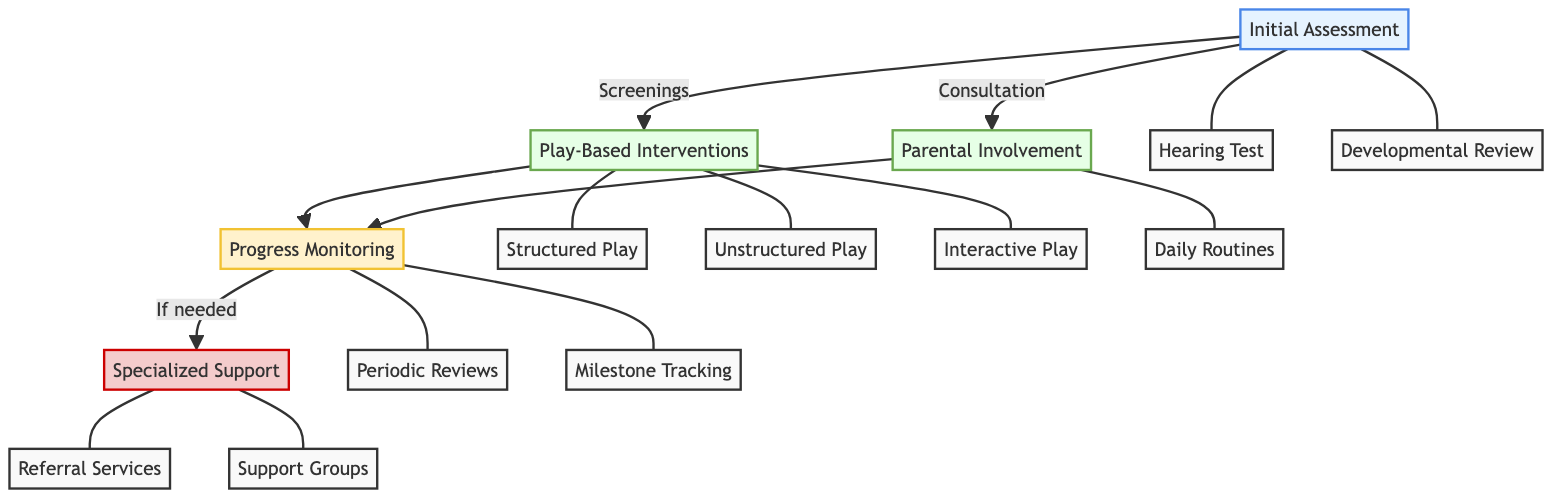What is the first step in the Clinical Pathway? The first step is "Initial Assessment," which indicates that the pathway begins with evaluating the children’s needs through discussion and screenings.
Answer: Initial Assessment How many types of Play-Based Interventions are there? The diagram shows three specific categories of Play-Based Interventions: Structured Play, Unstructured Play, and Interactive Play, indicating there are three types.
Answer: Three What materials are used in Structured Play? The diagram indicates that the materials used in Structured Play include "Age-appropriate books" and "Puppets for storytelling."
Answer: Age-appropriate books, Puppets for storytelling What is the frequency of Periodic Reviews for Progress Monitoring? According to the diagram, the frequency for Periodic Reviews is specified as "Every 3 months."
Answer: Every 3 months What do parents need to do in Daily Routines to promote language development? The diagram states that parents should engage in "Narration" of daily activities and ask "open-ended questions" to promote language development.
Answer: Narration, open-ended questions If a referral is needed, what specialized support can parents access? The diagram outlines that parents can refer their twins to "pediatric speech therapy" when specialized support is needed.
Answer: Pediatric speech therapy How does Parental Involvement connect to Progress Monitoring? The flow indicates that Parental Involvement feeds into Progress Monitoring, showing a direct relationship that highlights the importance of parental engagement in tracking progress.
Answer: Direct relationship What types of games are included in Interactive Play? The diagram specifies that "Simon Says" and "Hide and Seek" are games included in the Interactive Play category.
Answer: Simon Says, Hide and Seek 